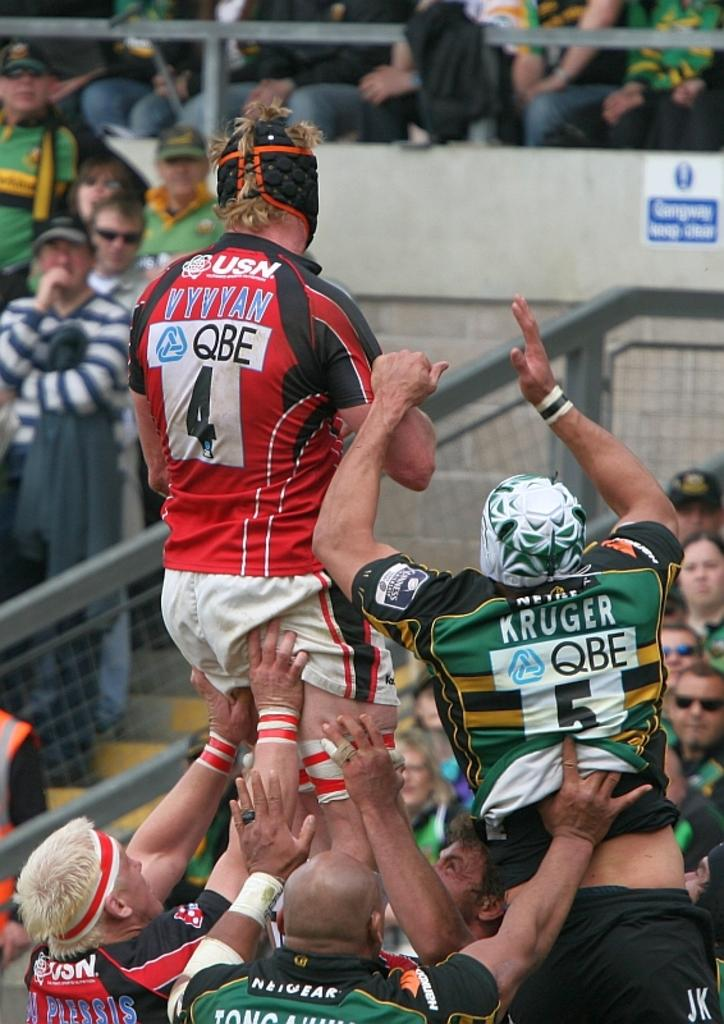What are the people in the image doing to the man? The people in the image are lifting a man. What can be seen in the background of the image? In the background of the image, there is a fence, a board, a wall, and a crowd. What type of cub is playing with a chain in the image? There is no cub or chain present in the image. How many toads can be seen in the image? There are no toads present in the image. 